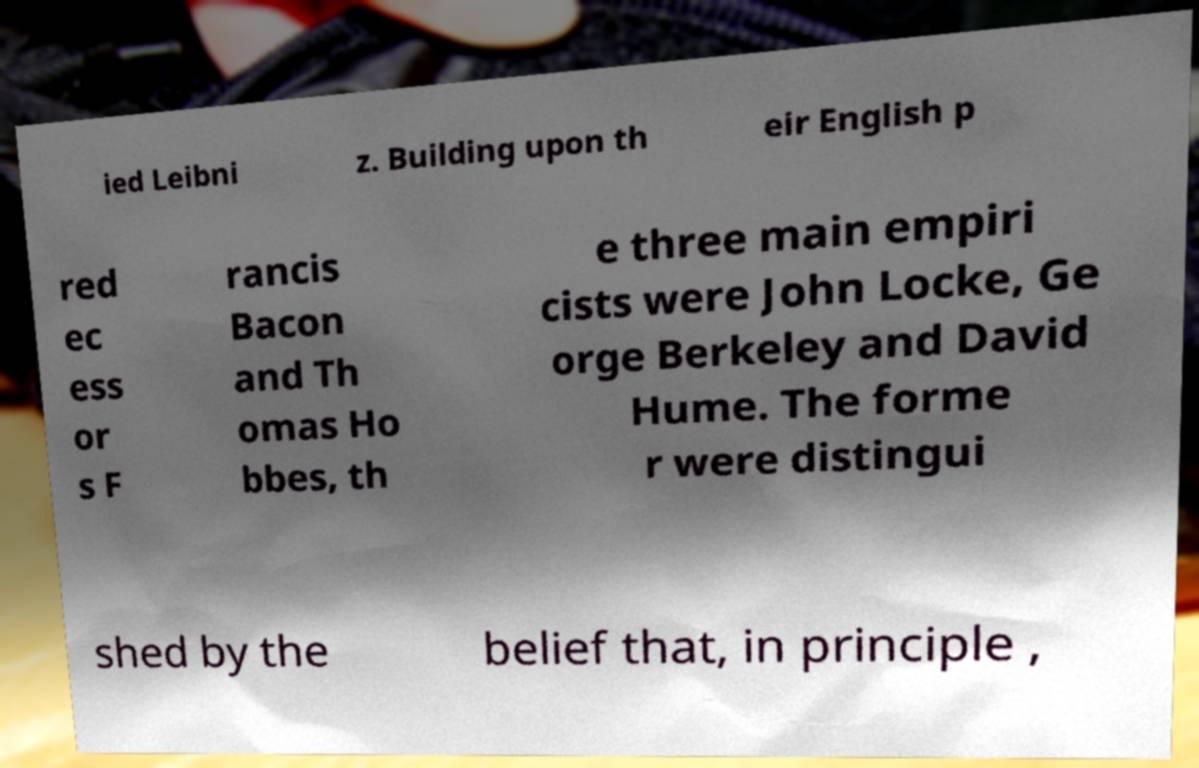There's text embedded in this image that I need extracted. Can you transcribe it verbatim? ied Leibni z. Building upon th eir English p red ec ess or s F rancis Bacon and Th omas Ho bbes, th e three main empiri cists were John Locke, Ge orge Berkeley and David Hume. The forme r were distingui shed by the belief that, in principle , 